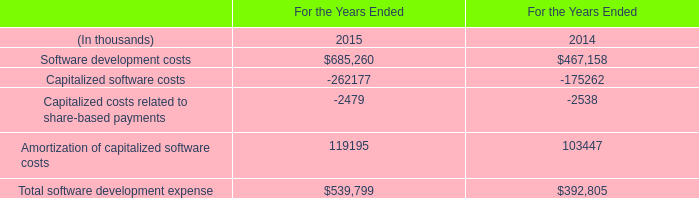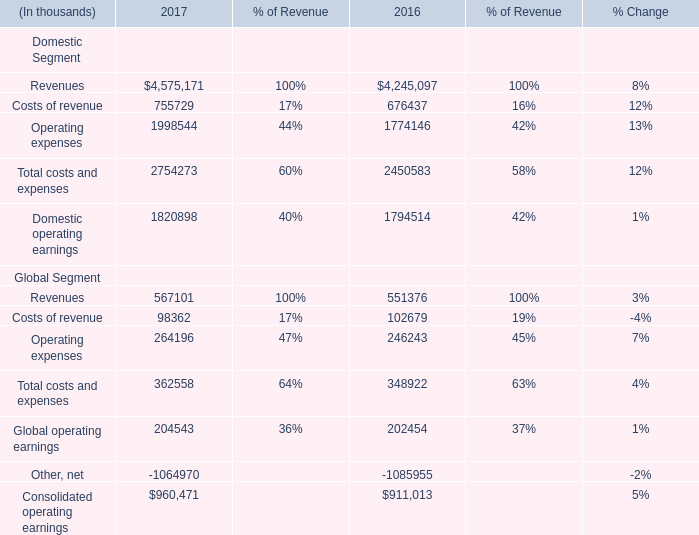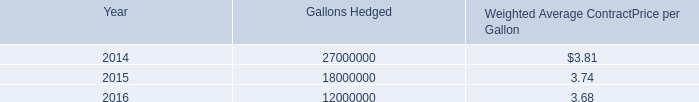What is the sum of Operating expenses of 2016, and Capitalized software costs of For the Years Ended 2014 ? 
Computations: (1774146.0 + 175262.0)
Answer: 1949408.0. 